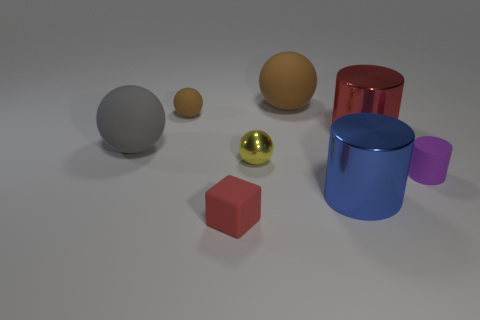What shape is the tiny object that is left of the tiny red thing?
Your answer should be compact. Sphere. What number of red cubes are the same material as the big gray thing?
Give a very brief answer. 1. Is the number of rubber balls to the right of the large gray sphere less than the number of tiny cyan metallic blocks?
Provide a short and direct response. No. There is a thing right of the cylinder that is behind the small rubber cylinder; what is its size?
Provide a short and direct response. Small. Do the small rubber block and the big metallic cylinder behind the large gray matte ball have the same color?
Offer a very short reply. Yes. What is the material of the brown thing that is the same size as the red matte thing?
Your response must be concise. Rubber. Are there fewer large metal cylinders in front of the yellow metal sphere than big things to the right of the tiny brown matte thing?
Give a very brief answer. Yes. There is a purple object that is in front of the tiny object to the left of the block; what shape is it?
Make the answer very short. Cylinder. Are there any big yellow metallic spheres?
Give a very brief answer. No. What color is the big ball that is in front of the red metal cylinder?
Offer a very short reply. Gray. 